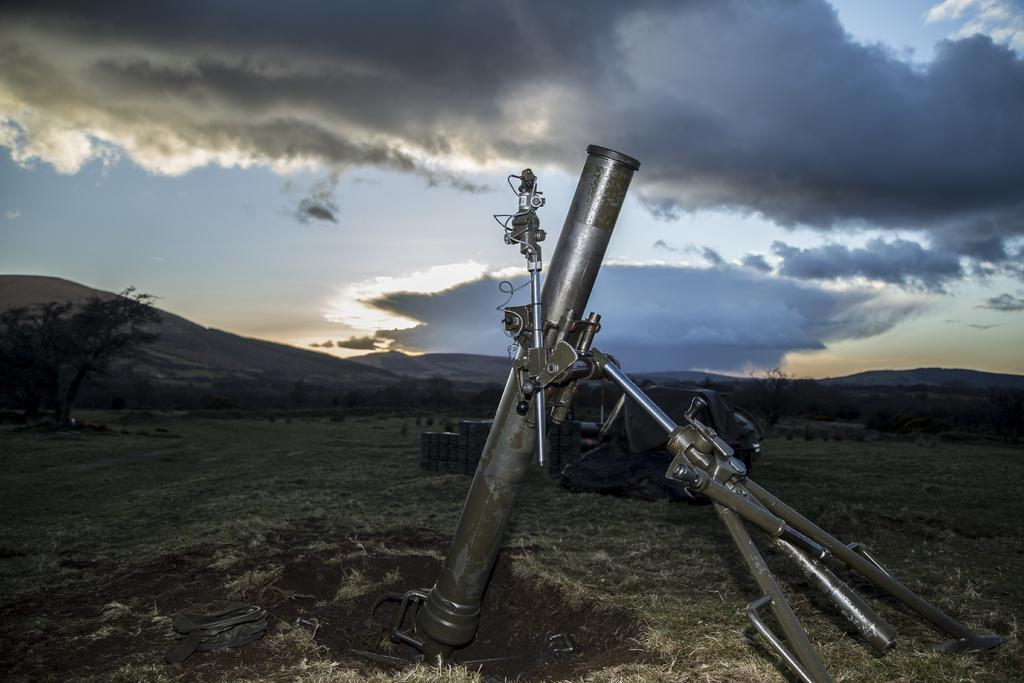What is the main object in the center of the image? There is a weapon in the center of the image. Where is the weapon located? The weapon is on the ground. What can be seen in the background of the image? There are trees, hills, and the sky visible in the background of the image. What is the condition of the sky in the image? The sky is visible in the background of the image, and there are clouds present. What type of coach can be seen driving through the hills in the image? There is no coach present in the image; it features a weapon on the ground with a background of trees, hills, and the sky. What arithmetic problem is being solved by the toad in the image? There is no toad or arithmetic problem present in the image; it only features a weapon on the ground and a background of trees, hills, and the sky. 